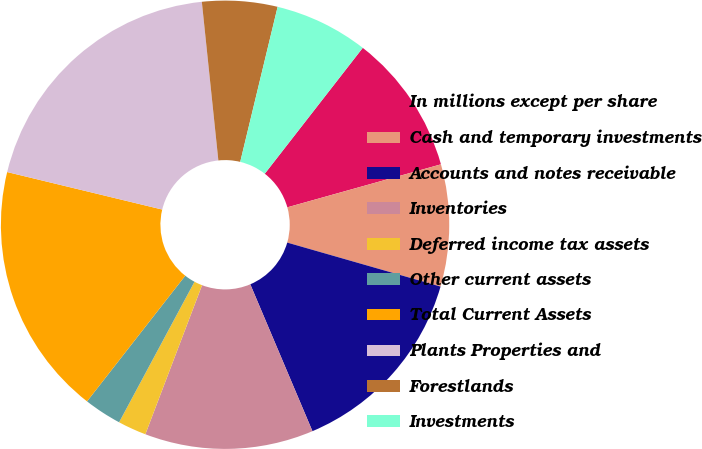Convert chart. <chart><loc_0><loc_0><loc_500><loc_500><pie_chart><fcel>In millions except per share<fcel>Cash and temporary investments<fcel>Accounts and notes receivable<fcel>Inventories<fcel>Deferred income tax assets<fcel>Other current assets<fcel>Total Current Assets<fcel>Plants Properties and<fcel>Forestlands<fcel>Investments<nl><fcel>10.13%<fcel>8.79%<fcel>14.18%<fcel>12.16%<fcel>2.05%<fcel>2.72%<fcel>18.22%<fcel>19.57%<fcel>5.42%<fcel>6.76%<nl></chart> 